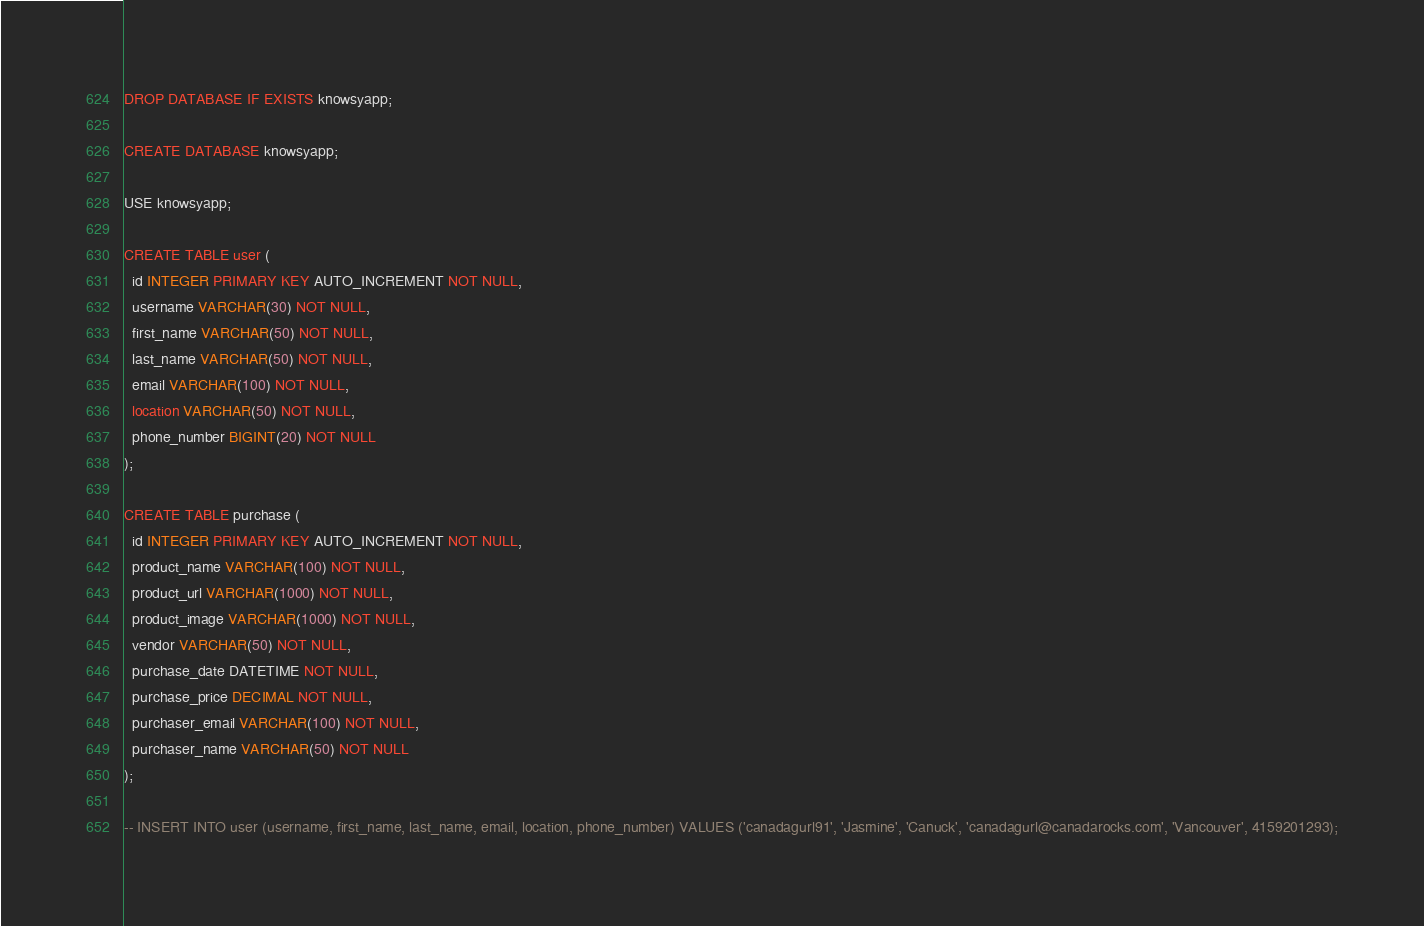<code> <loc_0><loc_0><loc_500><loc_500><_SQL_>DROP DATABASE IF EXISTS knowsyapp;

CREATE DATABASE knowsyapp;

USE knowsyapp;

CREATE TABLE user (
  id INTEGER PRIMARY KEY AUTO_INCREMENT NOT NULL,
  username VARCHAR(30) NOT NULL,
  first_name VARCHAR(50) NOT NULL,
  last_name VARCHAR(50) NOT NULL,
  email VARCHAR(100) NOT NULL,
  location VARCHAR(50) NOT NULL,
  phone_number BIGINT(20) NOT NULL
);

CREATE TABLE purchase (
  id INTEGER PRIMARY KEY AUTO_INCREMENT NOT NULL,
  product_name VARCHAR(100) NOT NULL,
  product_url VARCHAR(1000) NOT NULL,
  product_image VARCHAR(1000) NOT NULL,
  vendor VARCHAR(50) NOT NULL,
  purchase_date DATETIME NOT NULL,
  purchase_price DECIMAL NOT NULL,
  purchaser_email VARCHAR(100) NOT NULL,
  purchaser_name VARCHAR(50) NOT NULL
);

-- INSERT INTO user (username, first_name, last_name, email, location, phone_number) VALUES ('canadagurl91', 'Jasmine', 'Canuck', 'canadagurl@canadarocks.com', 'Vancouver', 4159201293);</code> 